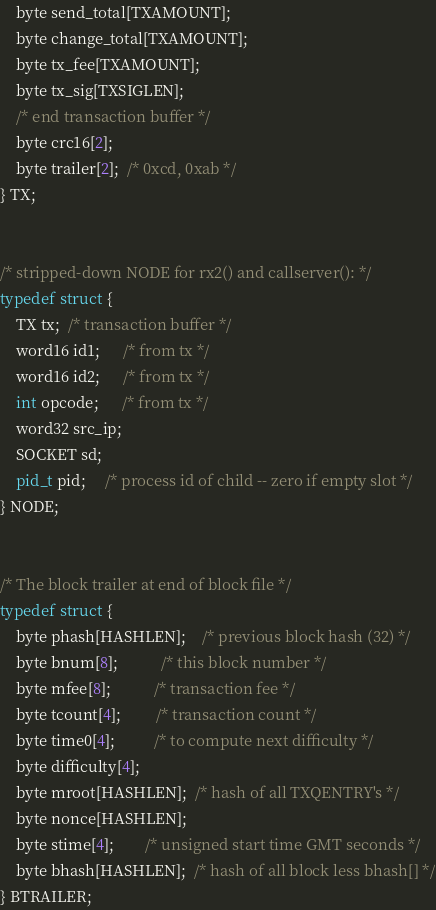<code> <loc_0><loc_0><loc_500><loc_500><_C_>	byte send_total[TXAMOUNT];
	byte change_total[TXAMOUNT];
	byte tx_fee[TXAMOUNT];
	byte tx_sig[TXSIGLEN];
	/* end transaction buffer */
	byte crc16[2];
	byte trailer[2];  /* 0xcd, 0xab */
} TX;


/* stripped-down NODE for rx2() and callserver(): */
typedef struct {
	TX tx;  /* transaction buffer */
	word16 id1;      /* from tx */
	word16 id2;      /* from tx */
	int opcode;      /* from tx */
	word32 src_ip;
	SOCKET sd;
	pid_t pid;     /* process id of child -- zero if empty slot */
} NODE;


/* The block trailer at end of block file */
typedef struct {
	byte phash[HASHLEN];    /* previous block hash (32) */
	byte bnum[8];           /* this block number */
	byte mfee[8];           /* transaction fee */
	byte tcount[4];         /* transaction count */
	byte time0[4];          /* to compute next difficulty */
	byte difficulty[4];
	byte mroot[HASHLEN];  /* hash of all TXQENTRY's */
	byte nonce[HASHLEN];
	byte stime[4];        /* unsigned start time GMT seconds */
	byte bhash[HASHLEN];  /* hash of all block less bhash[] */
} BTRAILER;
</code> 